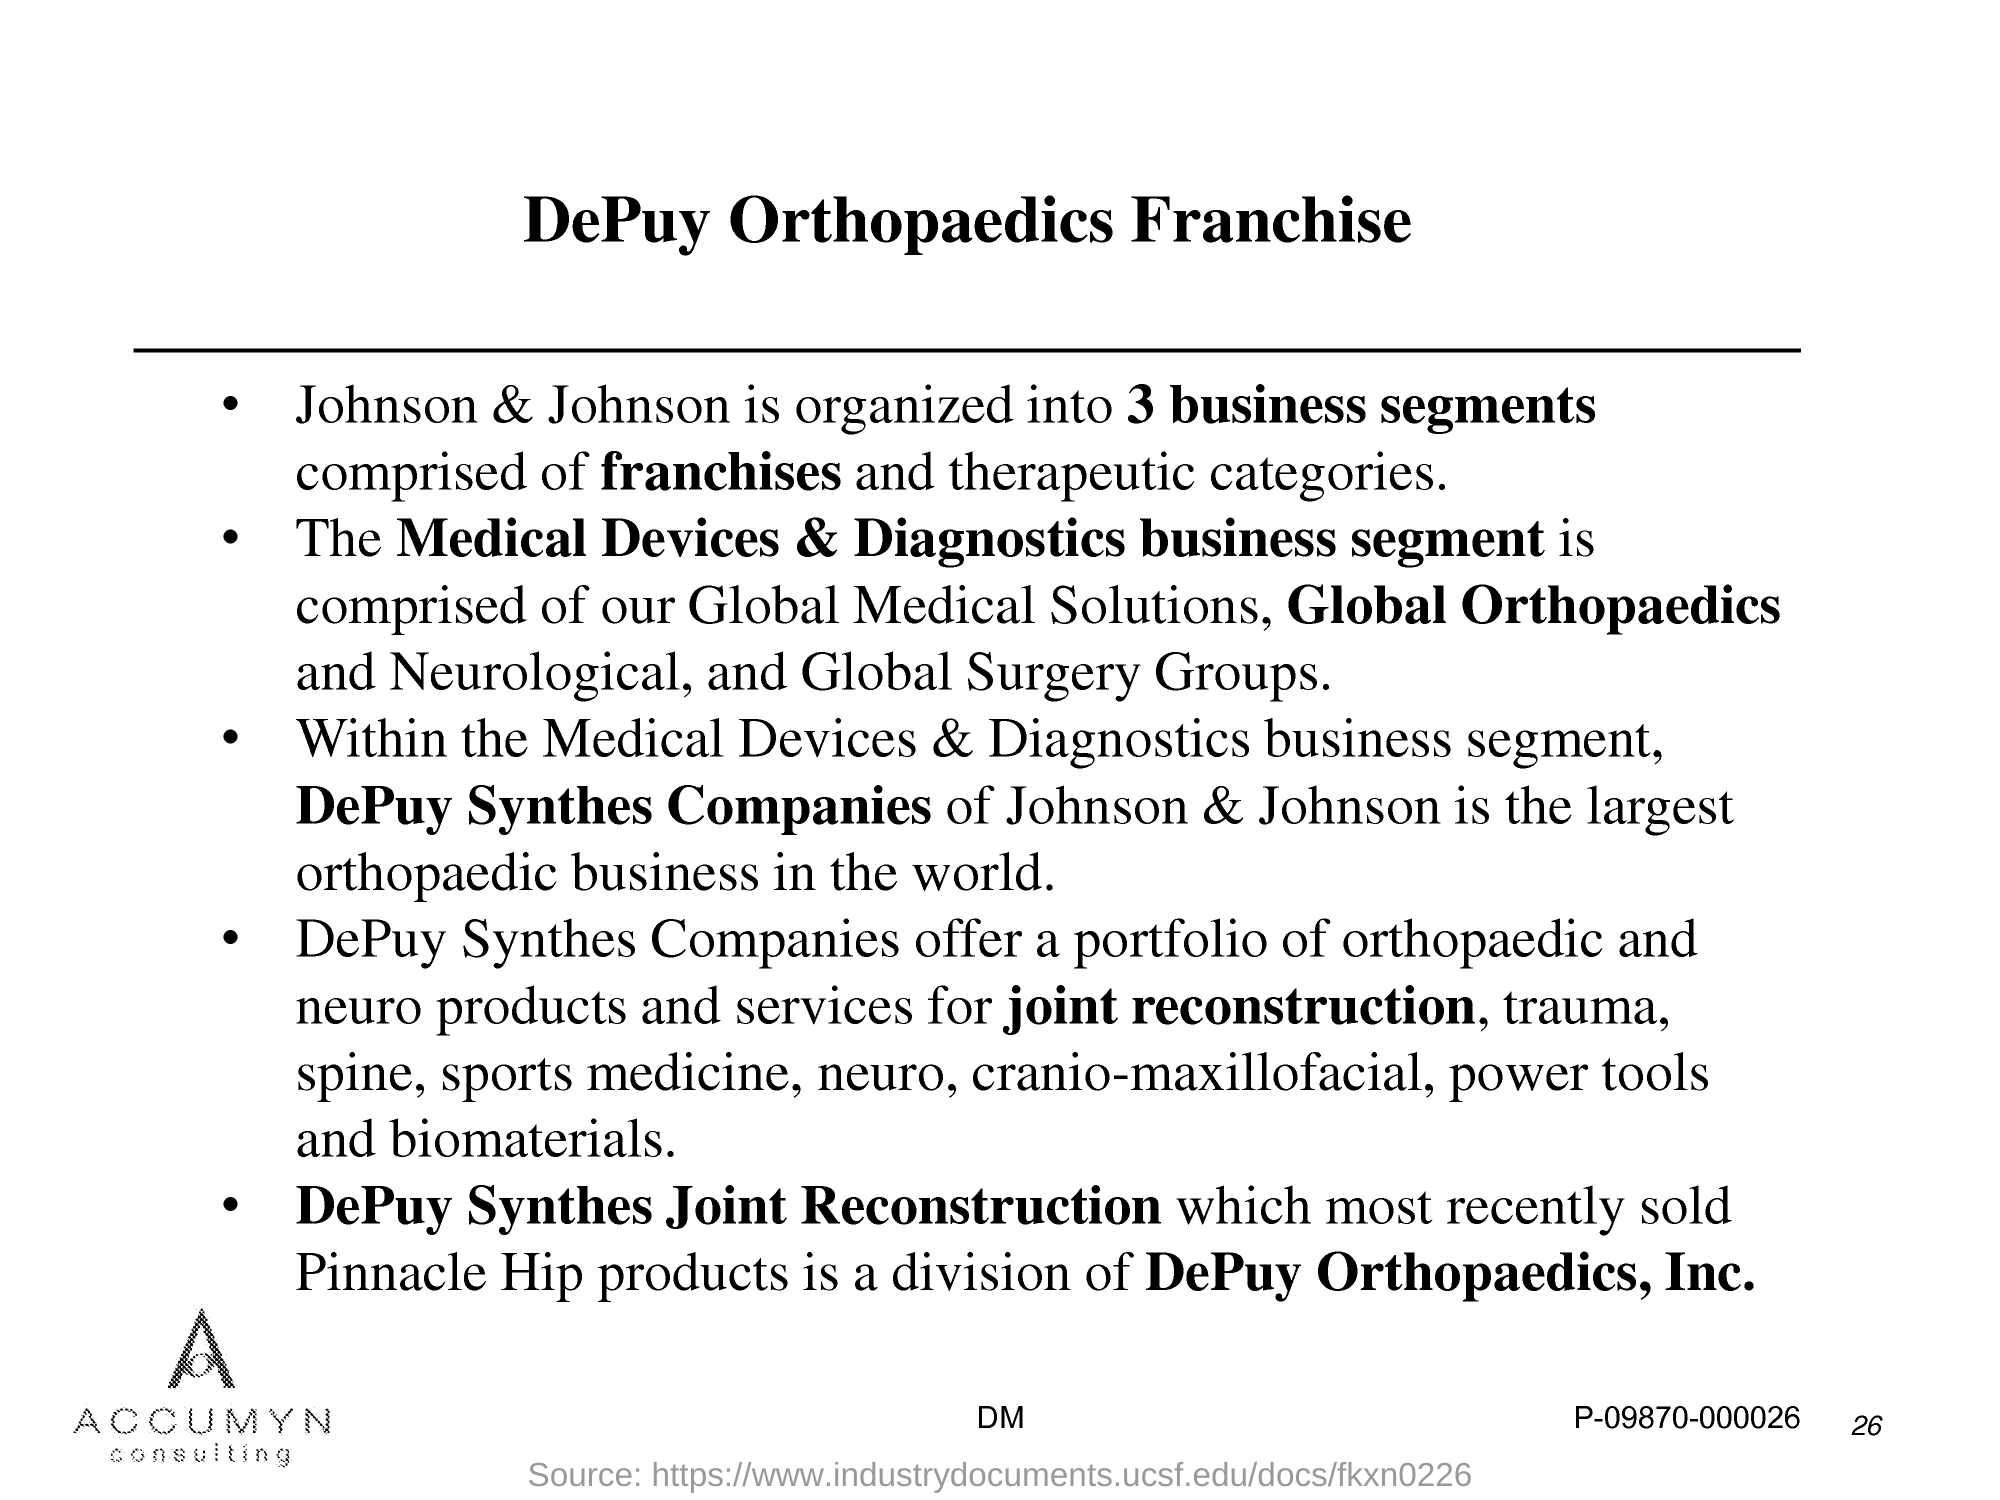List a handful of essential elements in this visual. DePuy Synthes Companies is a company that provides services for joint reconstruction. DePuy Synthes Companies offer a comprehensive portfolio of orthopaedic and neuro products, catering to the diverse needs of patients. The most recently sold Pinnacle Hip products are those from DePuy Synthes Joint Reconstruction. DePuy Synthes Companies provide services for cranio-maxillofacial. Johnson & Johnson's DePuy Synthes Companies are the largest orthopaedic business in the world. 